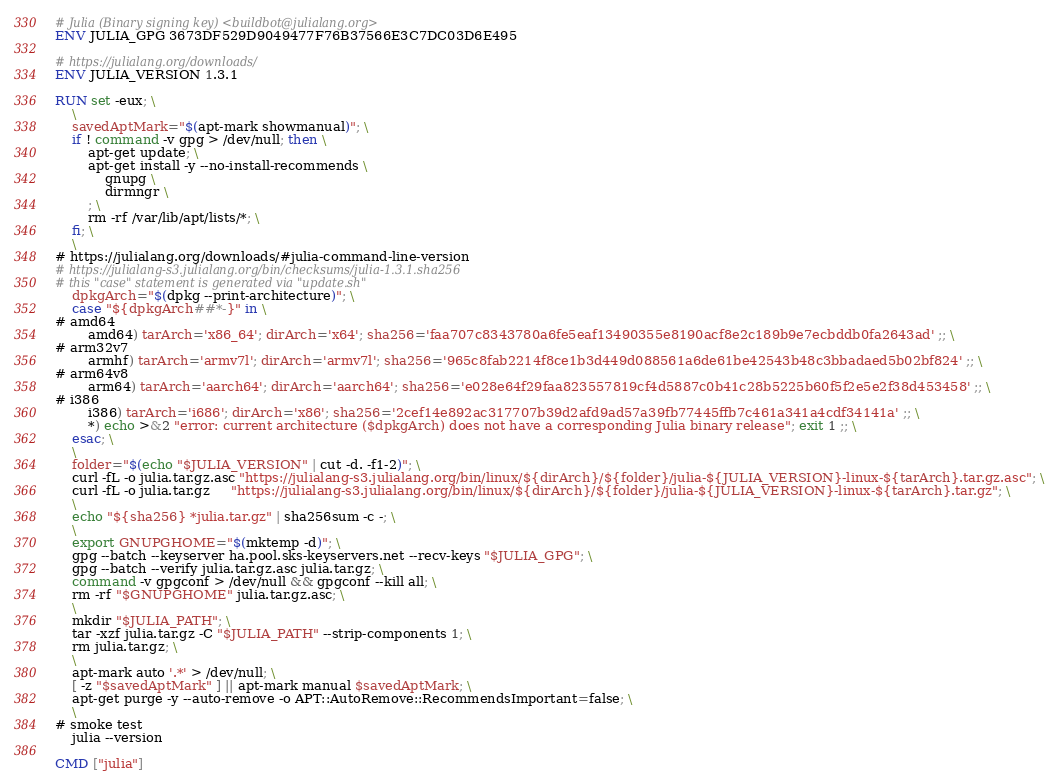Convert code to text. <code><loc_0><loc_0><loc_500><loc_500><_Dockerfile_># Julia (Binary signing key) <buildbot@julialang.org>
ENV JULIA_GPG 3673DF529D9049477F76B37566E3C7DC03D6E495

# https://julialang.org/downloads/
ENV JULIA_VERSION 1.3.1

RUN set -eux; \
	\
	savedAptMark="$(apt-mark showmanual)"; \
	if ! command -v gpg > /dev/null; then \
		apt-get update; \
		apt-get install -y --no-install-recommends \
			gnupg \
			dirmngr \
		; \
		rm -rf /var/lib/apt/lists/*; \
	fi; \
	\
# https://julialang.org/downloads/#julia-command-line-version
# https://julialang-s3.julialang.org/bin/checksums/julia-1.3.1.sha256
# this "case" statement is generated via "update.sh"
	dpkgArch="$(dpkg --print-architecture)"; \
	case "${dpkgArch##*-}" in \
# amd64
		amd64) tarArch='x86_64'; dirArch='x64'; sha256='faa707c8343780a6fe5eaf13490355e8190acf8e2c189b9e7ecbddb0fa2643ad' ;; \
# arm32v7
		armhf) tarArch='armv7l'; dirArch='armv7l'; sha256='965c8fab2214f8ce1b3d449d088561a6de61be42543b48c3bbadaed5b02bf824' ;; \
# arm64v8
		arm64) tarArch='aarch64'; dirArch='aarch64'; sha256='e028e64f29faa823557819cf4d5887c0b41c28b5225b60f5f2e5e2f38d453458' ;; \
# i386
		i386) tarArch='i686'; dirArch='x86'; sha256='2cef14e892ac317707b39d2afd9ad57a39fb77445ffb7c461a341a4cdf34141a' ;; \
		*) echo >&2 "error: current architecture ($dpkgArch) does not have a corresponding Julia binary release"; exit 1 ;; \
	esac; \
	\
	folder="$(echo "$JULIA_VERSION" | cut -d. -f1-2)"; \
	curl -fL -o julia.tar.gz.asc "https://julialang-s3.julialang.org/bin/linux/${dirArch}/${folder}/julia-${JULIA_VERSION}-linux-${tarArch}.tar.gz.asc"; \
	curl -fL -o julia.tar.gz     "https://julialang-s3.julialang.org/bin/linux/${dirArch}/${folder}/julia-${JULIA_VERSION}-linux-${tarArch}.tar.gz"; \
	\
	echo "${sha256} *julia.tar.gz" | sha256sum -c -; \
	\
	export GNUPGHOME="$(mktemp -d)"; \
	gpg --batch --keyserver ha.pool.sks-keyservers.net --recv-keys "$JULIA_GPG"; \
	gpg --batch --verify julia.tar.gz.asc julia.tar.gz; \
	command -v gpgconf > /dev/null && gpgconf --kill all; \
	rm -rf "$GNUPGHOME" julia.tar.gz.asc; \
	\
	mkdir "$JULIA_PATH"; \
	tar -xzf julia.tar.gz -C "$JULIA_PATH" --strip-components 1; \
	rm julia.tar.gz; \
	\
	apt-mark auto '.*' > /dev/null; \
	[ -z "$savedAptMark" ] || apt-mark manual $savedAptMark; \
	apt-get purge -y --auto-remove -o APT::AutoRemove::RecommendsImportant=false; \
	\
# smoke test
	julia --version

CMD ["julia"]
</code> 